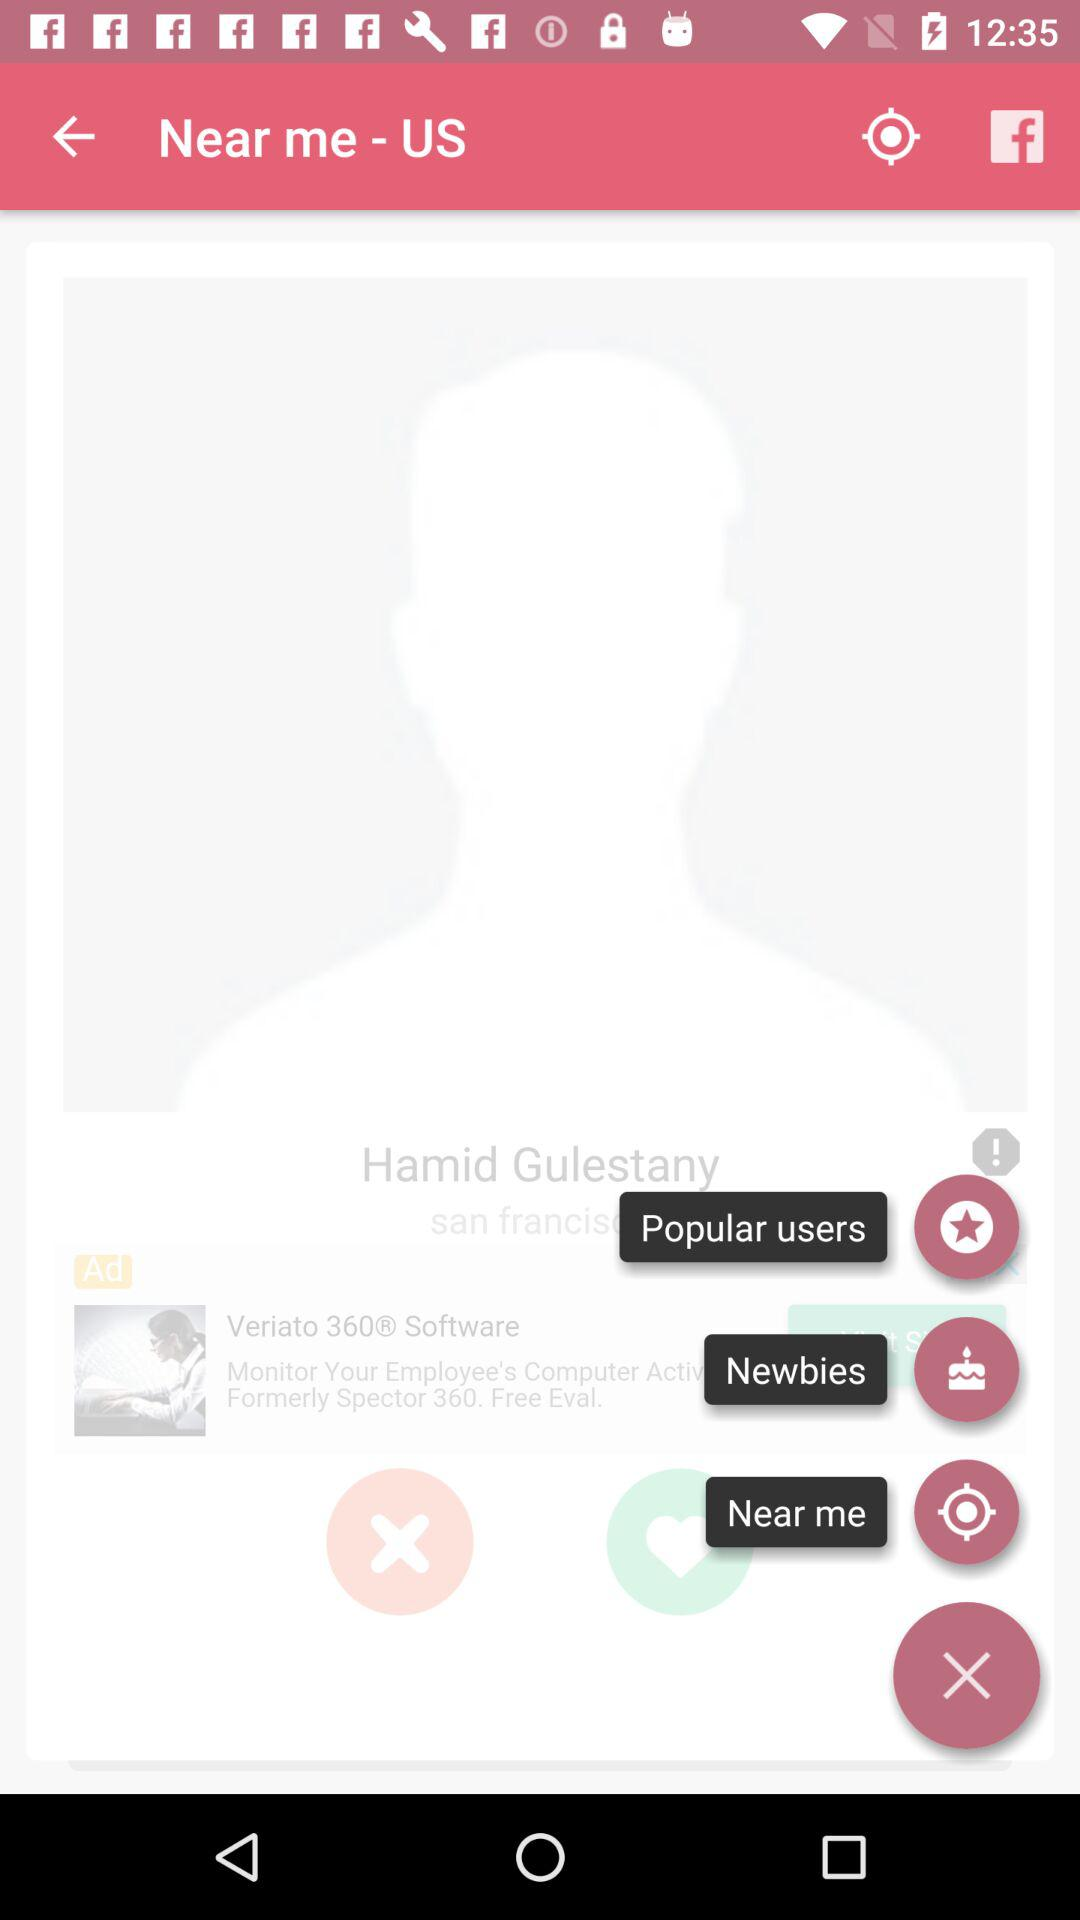What is the name of the profile? The name of the profile is Hamid Gulestany. 